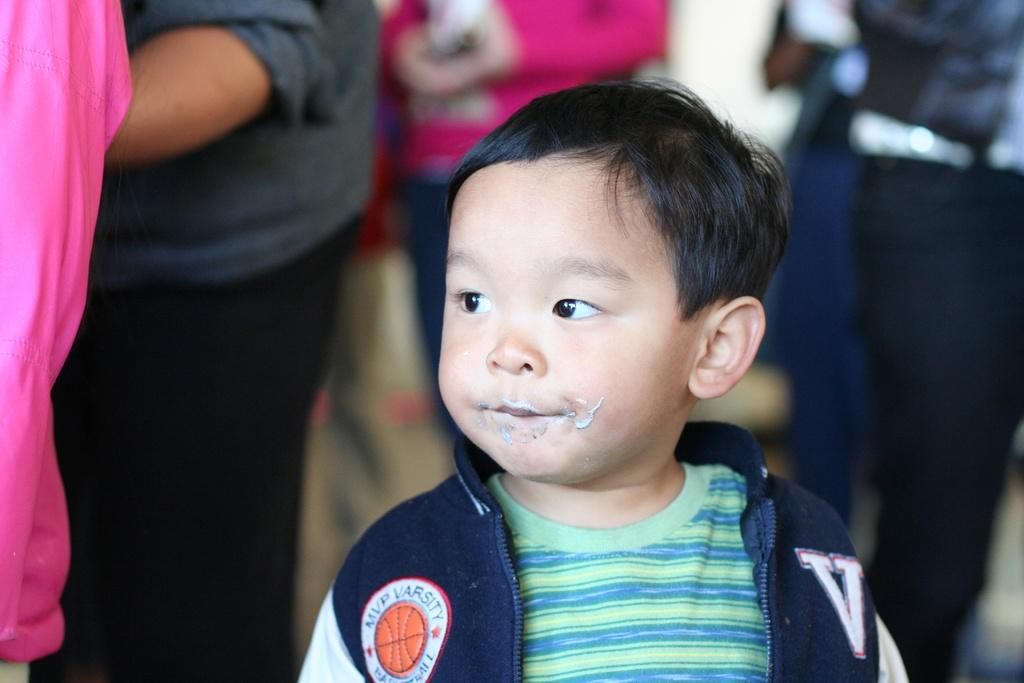<image>
Write a terse but informative summary of the picture. a boy in a jacket and the word varsity on his sleeve 